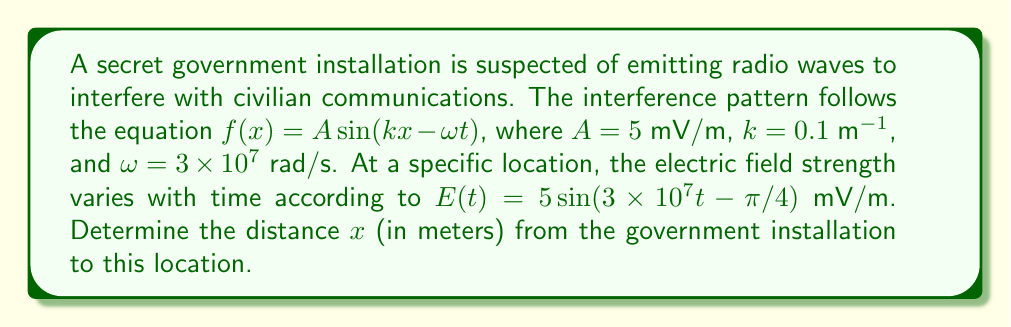Provide a solution to this math problem. To solve this problem, we need to compare the general form of the wave equation with the specific equation given for the location:

1) General form: $f(x) = A \sin(kx - \omega t)$
2) Specific form: $E(t) = 5 \sin(3 \times 10^7 t - \pi/4)$

We can see that the amplitude $A = 5$ mV/m matches in both equations.

The phase of the sine function in the specific form is $3 \times 10^7 t - \pi/4$. Comparing this to the general form $kx - \omega t$, we can deduce:

3) $\omega t = 3 \times 10^7 t$, which confirms $\omega = 3 \times 10^7$ rad/s
4) $kx = \pi/4$

Now we can solve for $x$ using the equation from step 4:

$$x = \frac{\pi/4}{k} = \frac{\pi/4}{0.1} = \frac{5\pi}{2} \approx 7.85$$

Therefore, the distance from the government installation to the specific location is approximately 7.85 meters.
Answer: $x \approx 7.85$ meters 